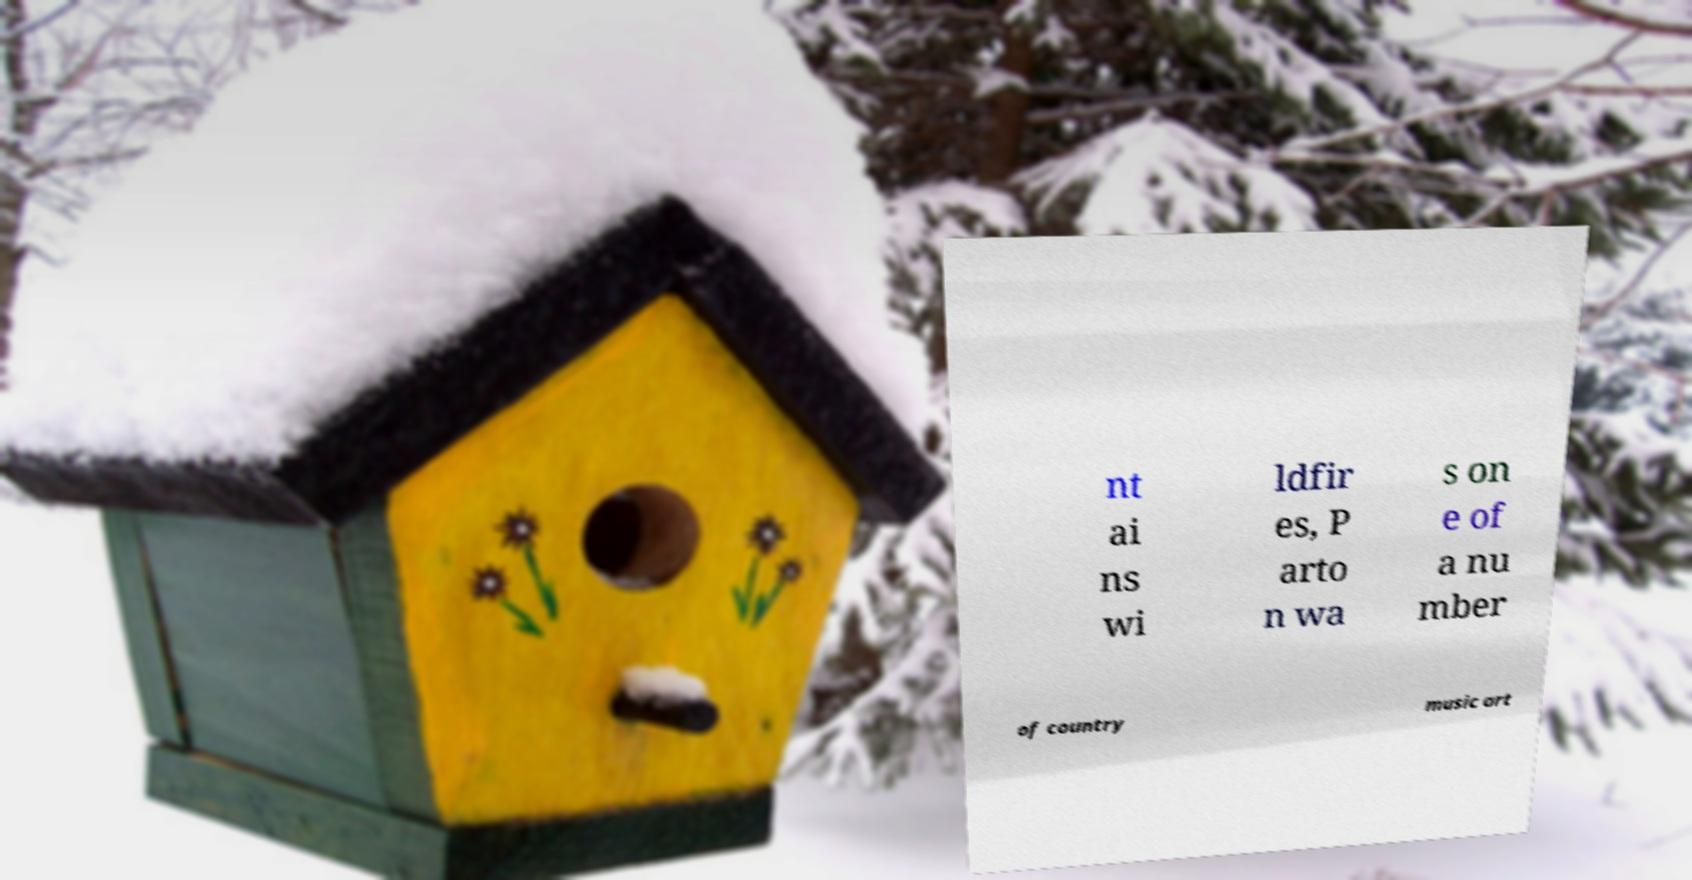What messages or text are displayed in this image? I need them in a readable, typed format. nt ai ns wi ldfir es, P arto n wa s on e of a nu mber of country music art 